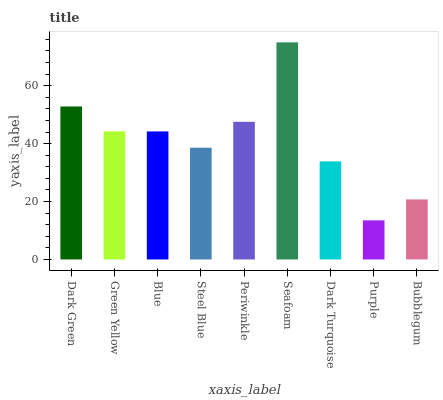Is Purple the minimum?
Answer yes or no. Yes. Is Seafoam the maximum?
Answer yes or no. Yes. Is Green Yellow the minimum?
Answer yes or no. No. Is Green Yellow the maximum?
Answer yes or no. No. Is Dark Green greater than Green Yellow?
Answer yes or no. Yes. Is Green Yellow less than Dark Green?
Answer yes or no. Yes. Is Green Yellow greater than Dark Green?
Answer yes or no. No. Is Dark Green less than Green Yellow?
Answer yes or no. No. Is Blue the high median?
Answer yes or no. Yes. Is Blue the low median?
Answer yes or no. Yes. Is Steel Blue the high median?
Answer yes or no. No. Is Dark Turquoise the low median?
Answer yes or no. No. 